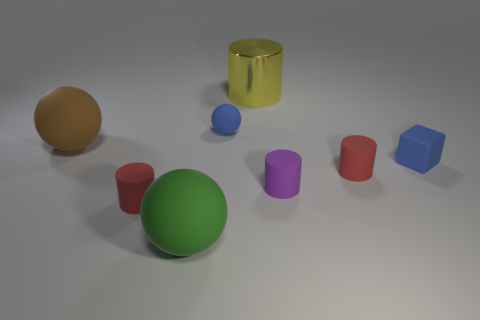What is the size of the cylinder behind the brown ball? The cylinder behind the brown ball is relatively large in comparison to the other objects in the image. It appears to be approximately twice the height of the smaller cylinders and has a diameter larger than the brown ball in the foreground. 